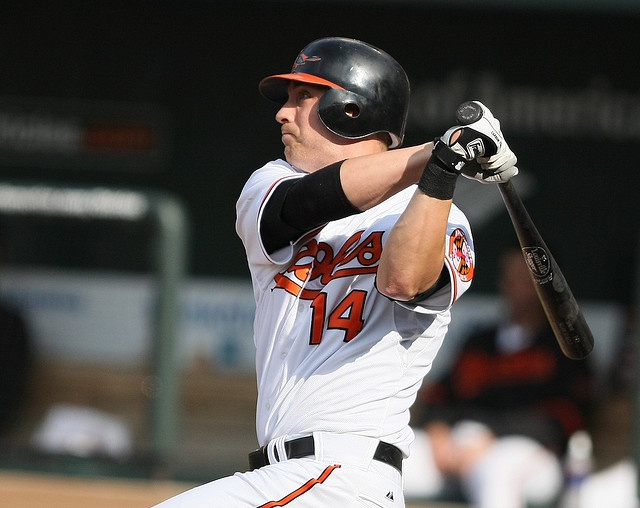Describe the objects in this image and their specific colors. I can see people in black, white, darkgray, and gray tones and baseball bat in black and gray tones in this image. 